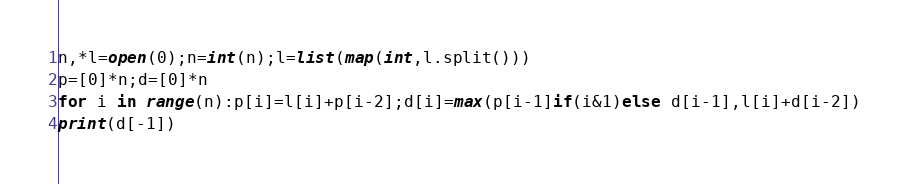<code> <loc_0><loc_0><loc_500><loc_500><_Python_>n,*l=open(0);n=int(n);l=list(map(int,l.split()))
p=[0]*n;d=[0]*n
for i in range(n):p[i]=l[i]+p[i-2];d[i]=max(p[i-1]if(i&1)else d[i-1],l[i]+d[i-2])
print(d[-1])</code> 